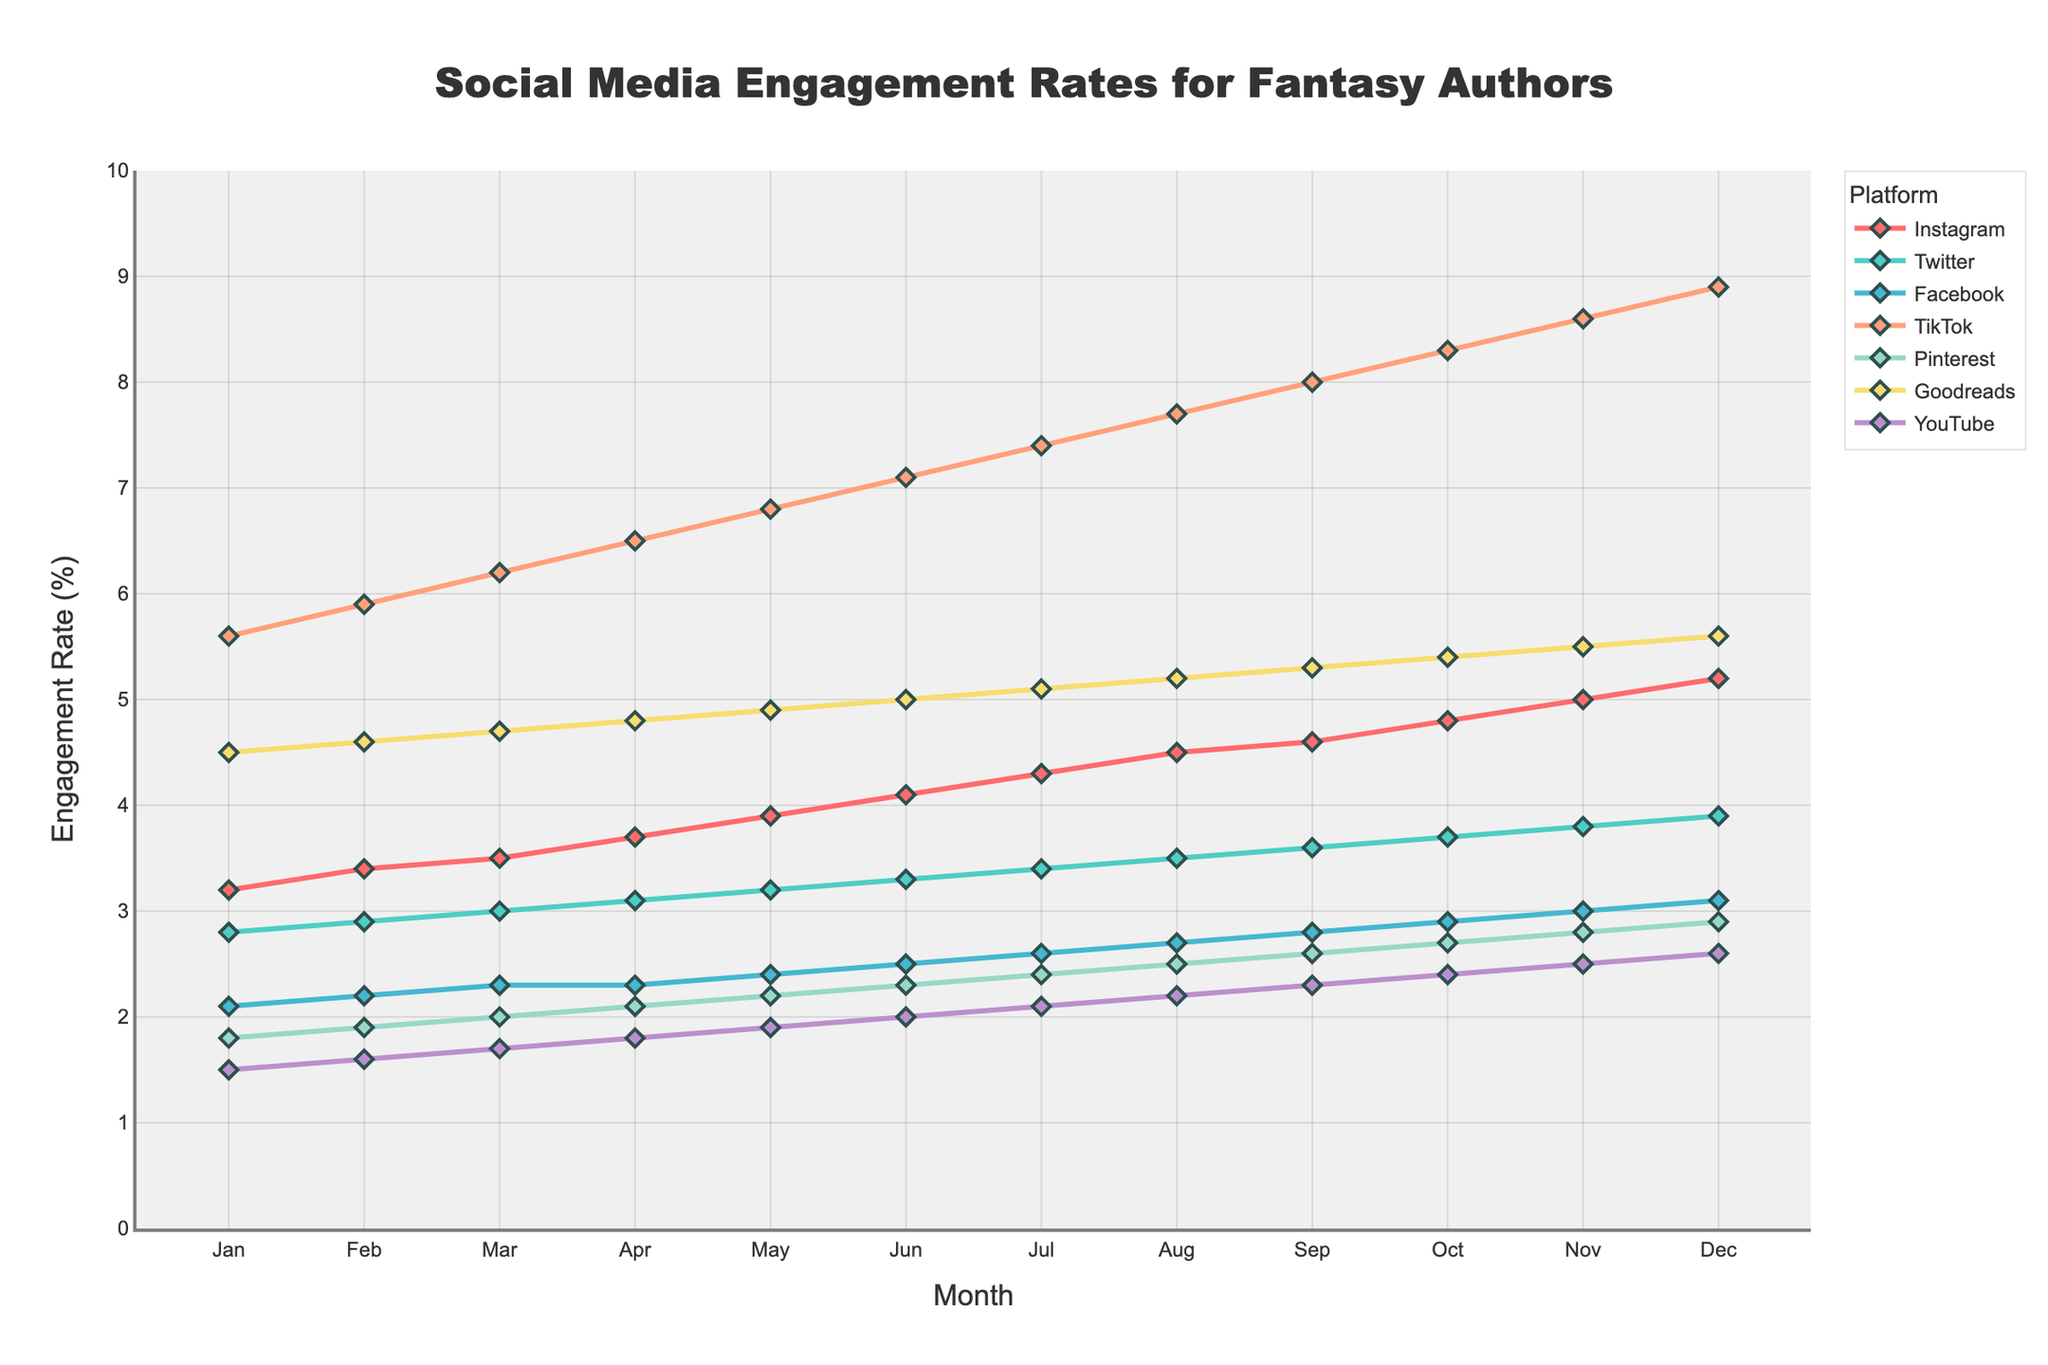In which month does TikTok have the highest engagement rate? By reviewing the figure, it is visible that TikTok's engagement rate is highest in December as it continuously increases from January to December.
Answer: December Which platform has the lowest engagement rate in January? By comparing all platforms’ engagement rates in January, YouTube has the lowest engagement rate.
Answer: YouTube Between Instagram and Twitter, which platform shows a higher engagement rate in June? In June, Instagram's engagement rate is 4.1, while Twitter's engagement rate is 3.3. Therefore, Instagram has a higher engagement rate.
Answer: Instagram What is the average engagement rate of Facebook in the first half of the year (January to June)? Facebook's engagement rates from January to June are 2.1, 2.2, 2.3, 2.3, 2.4, and 2.5. The average is calculated as (2.1 + 2.2 + 2.3 + 2.3 + 2.4 + 2.5) / 6 = 2.3.
Answer: 2.3 By how much does Goodreads' engagement rate increase from January to December? Goodreads' engagement rate starts at 4.5 in January and increases to 5.6 in December. The increase is 5.6 - 4.5 = 1.1.
Answer: 1.1 Which platform shows the most significant month-over-month growth rate throughout the year? By comparing all platforms month-over-month, TikTok shows the most considerable growth as its rate increases from 5.6 in January to 8.9 in December.
Answer: TikTok In which month do Instagram and Facebook have the same engagement rate? By checking both Instagram and Facebook's engagement rates across all months, they both have an engagement rate of 2.3 in March.
Answer: March Which platform has the highest engagement rate overall at any point during the year? By looking at the figure, TikTok has the highest engagement rate overall when it reaches 8.9 in December.
Answer: TikTok What is the total engagement rate for YouTube over the year? Summing the engagement rates for YouTube from January to December: 1.5 + 1.6 + 1.7 + 1.8 + 1.9 + 2.0 + 2.1 + 2.2 + 2.3 + 2.4 + 2.5 + 2.6, the total is 26.6.
Answer: 26.6 